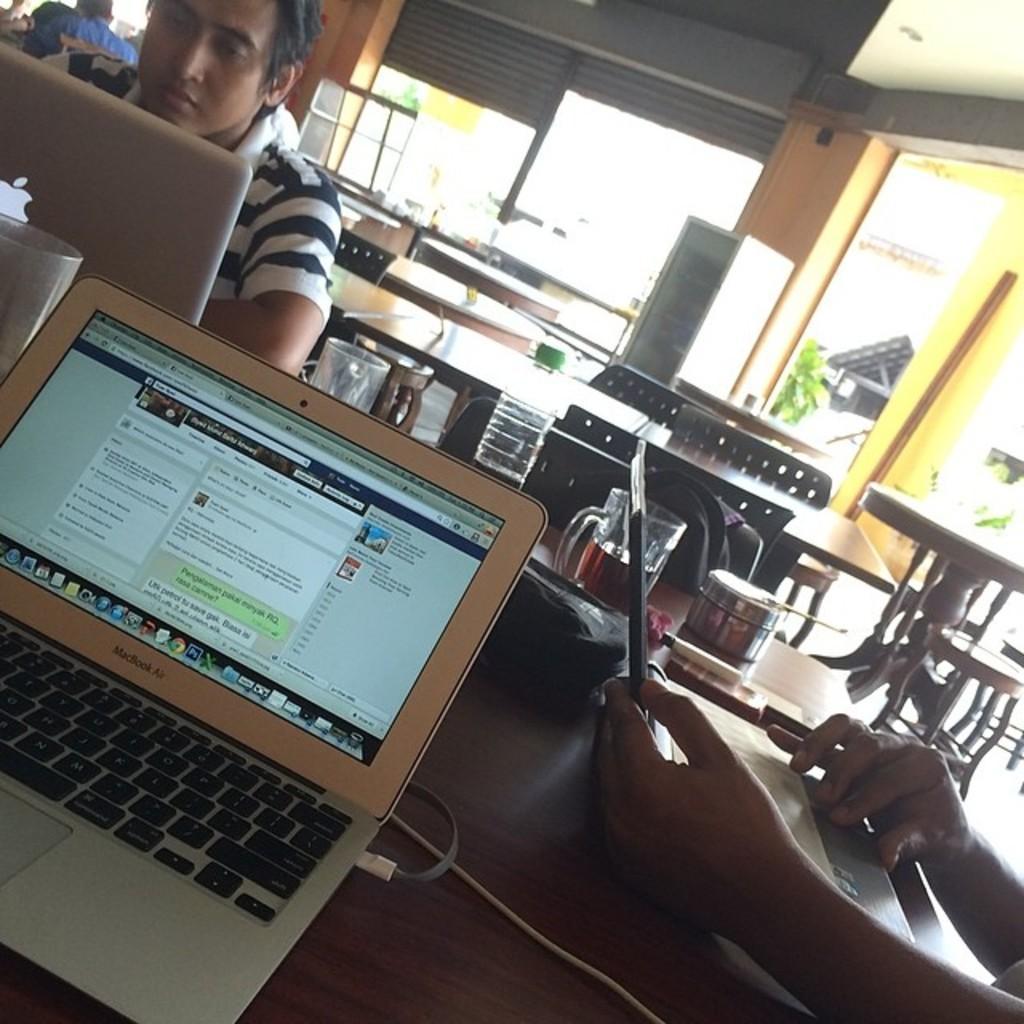How would you summarize this image in a sentence or two? There is a table in the given picture. On this table there is a laptop, glasses and a person sitting in front of a laptop. In the background there are some tables and chairs hire. We can observe a pillar too. 